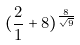Convert formula to latex. <formula><loc_0><loc_0><loc_500><loc_500>( \frac { 2 } { 1 } + 8 ) ^ { \frac { 8 } { \sqrt { 9 } } }</formula> 